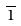<formula> <loc_0><loc_0><loc_500><loc_500>\overline { 1 }</formula> 